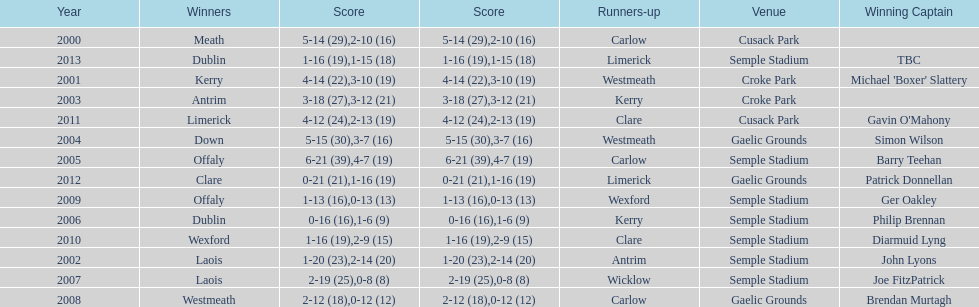How many winners won in semple stadium? 7. 